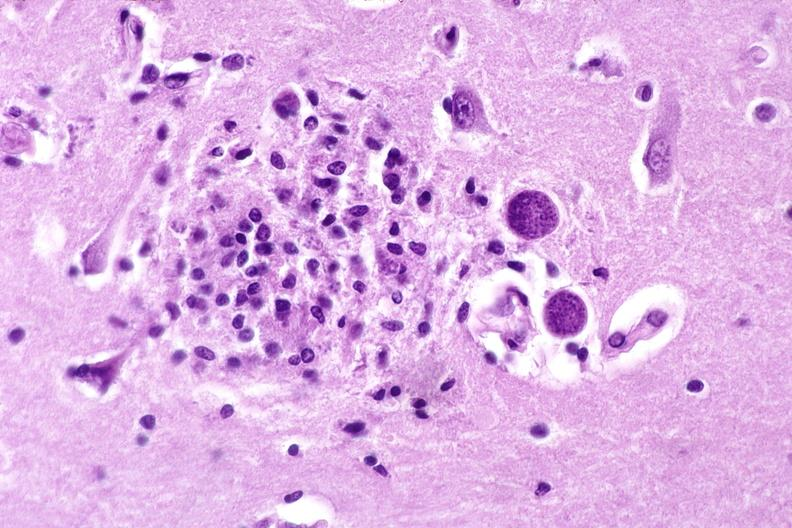what is present?
Answer the question using a single word or phrase. Nervous 